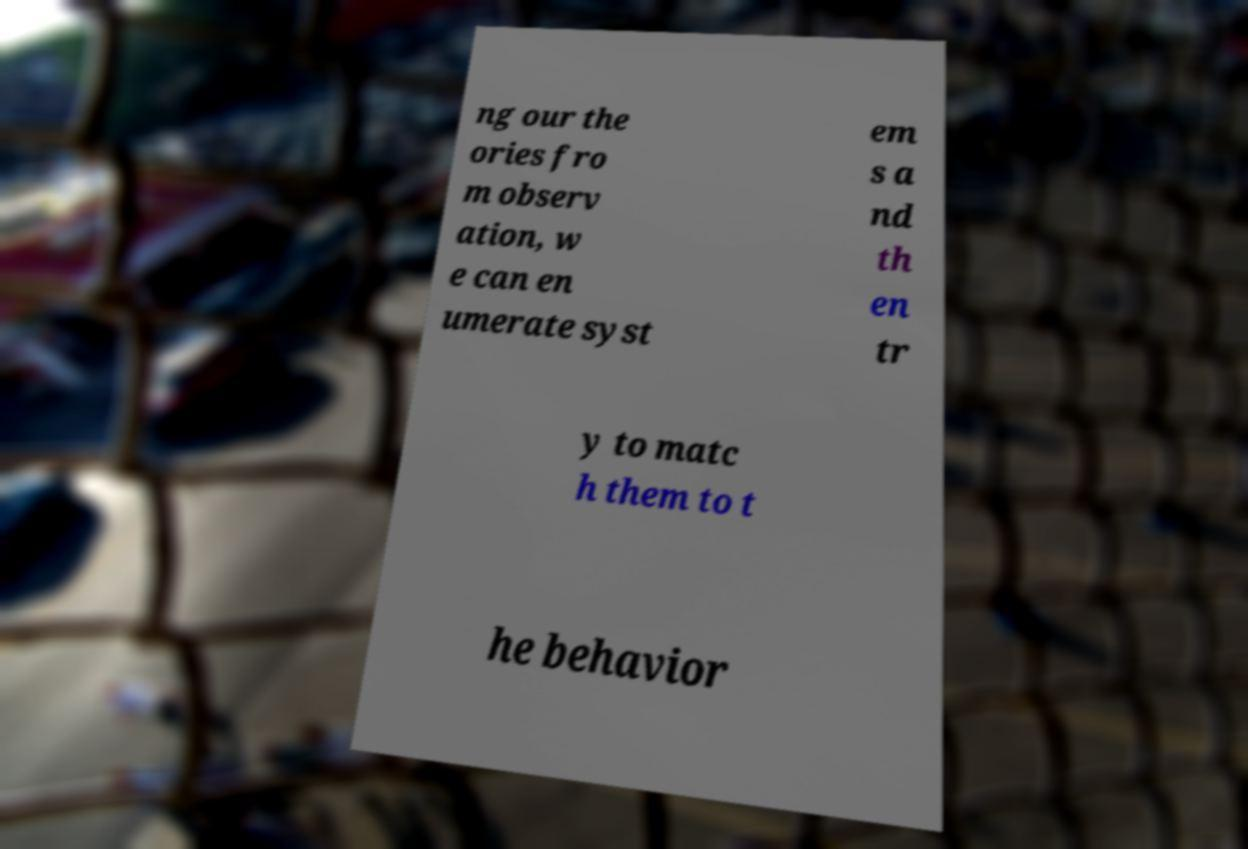Could you assist in decoding the text presented in this image and type it out clearly? ng our the ories fro m observ ation, w e can en umerate syst em s a nd th en tr y to matc h them to t he behavior 